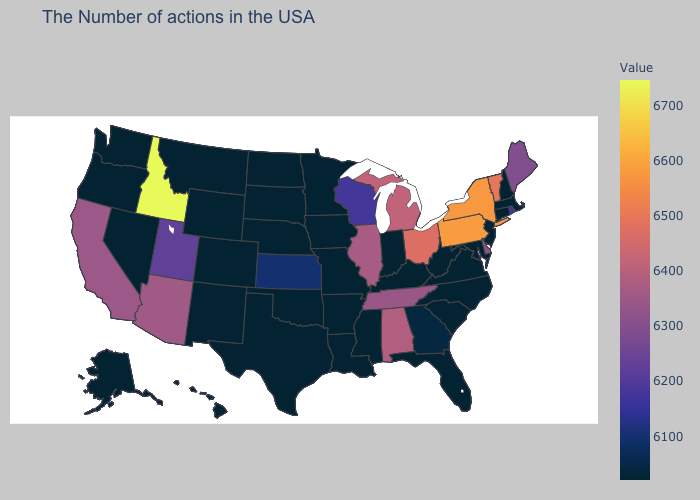Which states have the highest value in the USA?
Give a very brief answer. Idaho. Which states have the lowest value in the USA?
Answer briefly. Massachusetts, New Hampshire, Connecticut, New Jersey, Maryland, Virginia, North Carolina, South Carolina, West Virginia, Florida, Kentucky, Indiana, Mississippi, Louisiana, Missouri, Arkansas, Minnesota, Iowa, Nebraska, Oklahoma, Texas, South Dakota, North Dakota, Wyoming, Colorado, New Mexico, Montana, Nevada, Washington, Oregon, Alaska. Among the states that border Wisconsin , does Michigan have the highest value?
Short answer required. Yes. Among the states that border Minnesota , which have the lowest value?
Concise answer only. Iowa, South Dakota, North Dakota. 